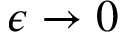<formula> <loc_0><loc_0><loc_500><loc_500>\epsilon \to 0</formula> 